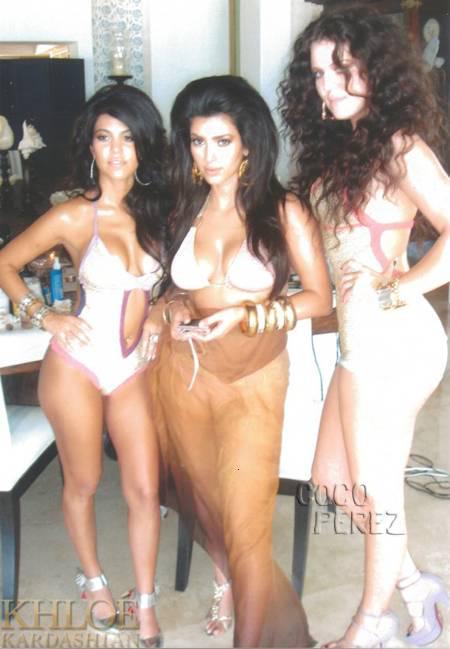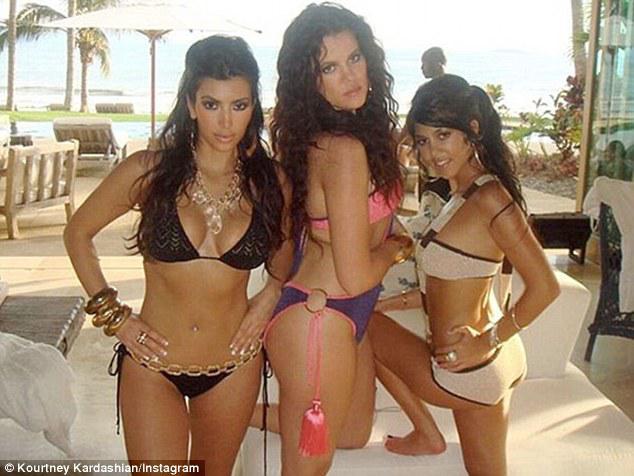The first image is the image on the left, the second image is the image on the right. Analyze the images presented: Is the assertion "A model's bare foot appears in at least one of the images." valid? Answer yes or no. Yes. 